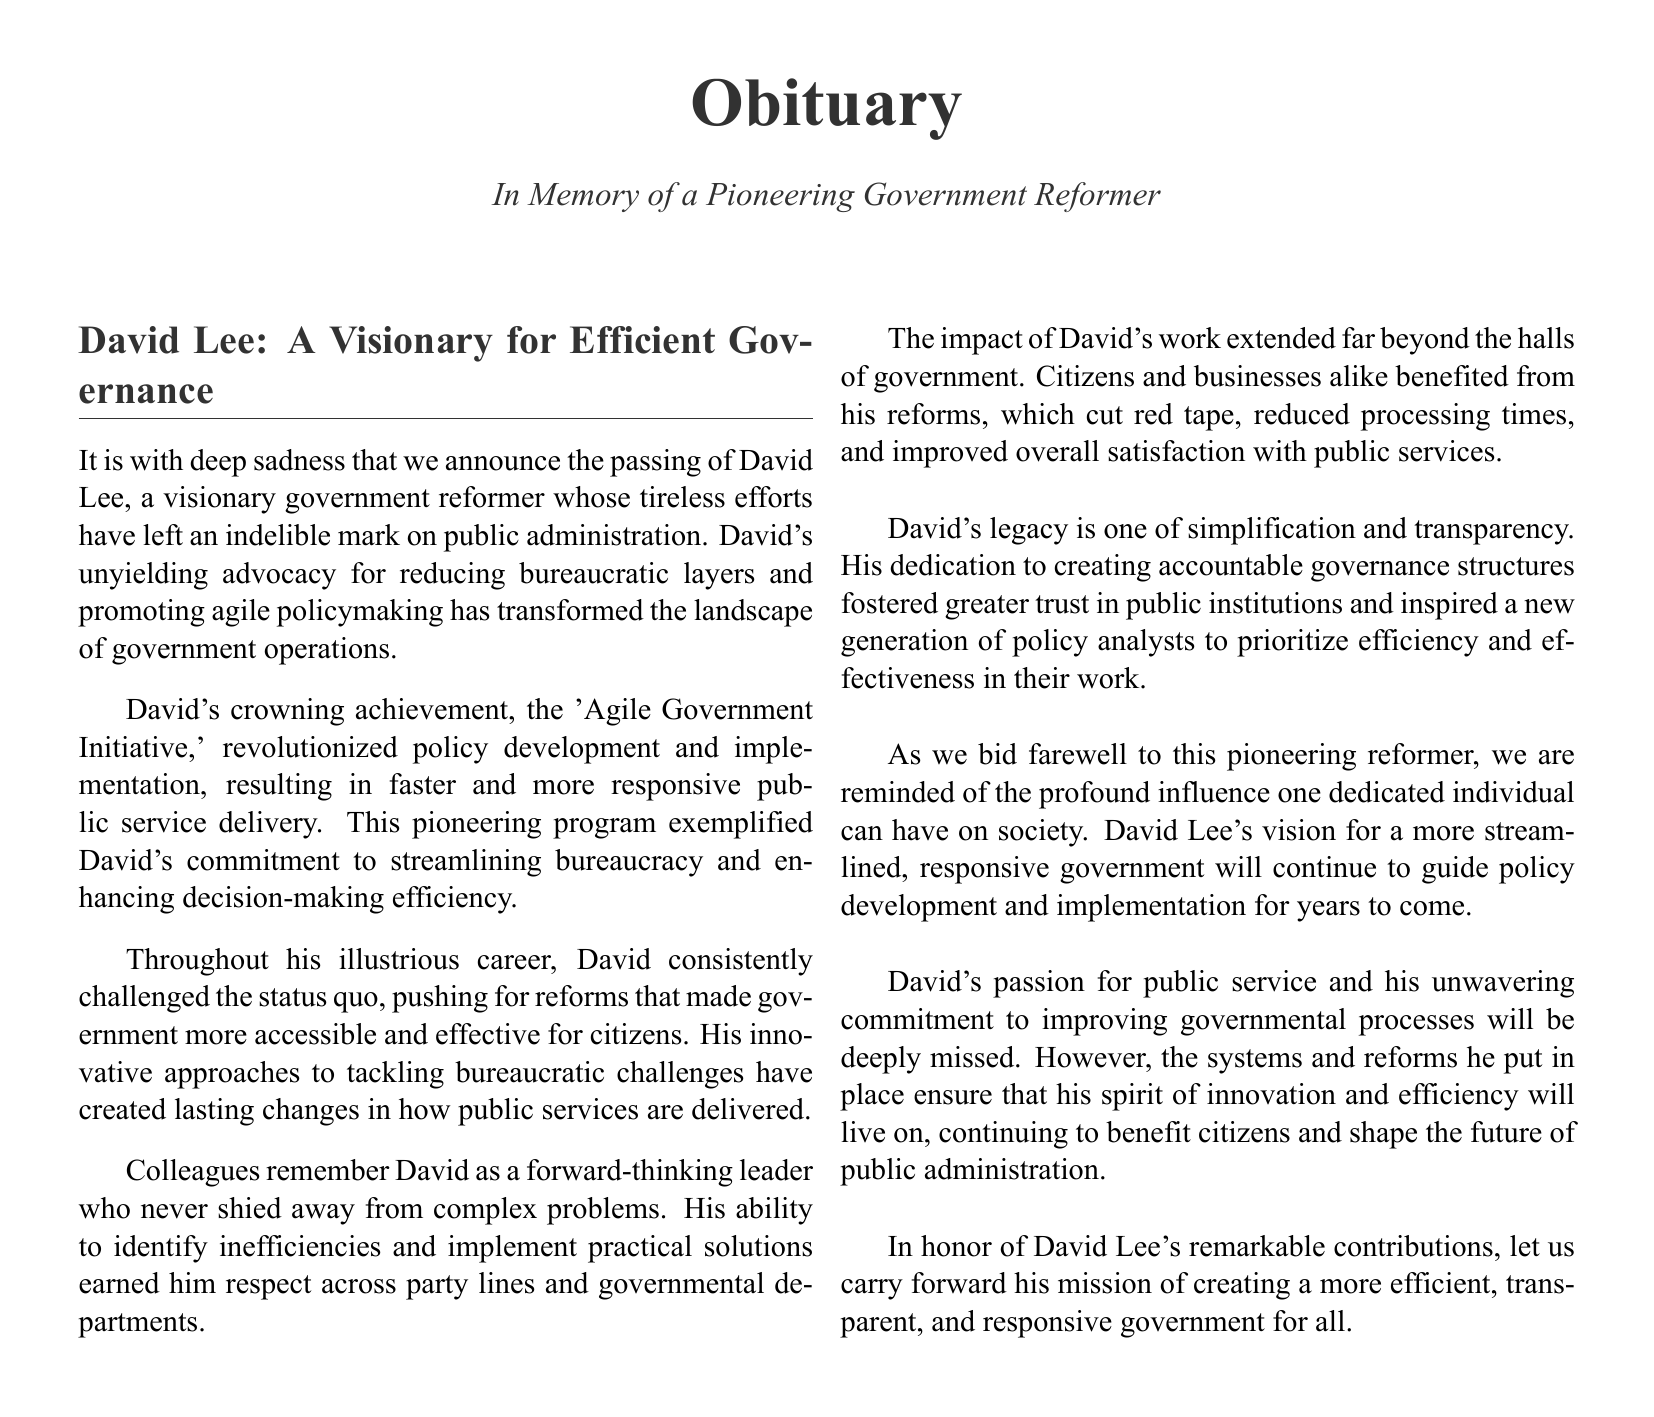What was David Lee known for? David Lee was known for being a visionary government reformer whose advocacy for reducing bureaucratic layers transformed public administration.
Answer: Visionary government reformer What significant program did David Lee implement? The significant program David Lee implemented is known as the 'Agile Government Initiative,' which revolutionized policy development.
Answer: Agile Government Initiative How did David Lee's reforms impact citizens? David Lee's reforms cut red tape, reduced processing times, and improved overall satisfaction with public services for citizens and businesses.
Answer: Cut red tape, reduced processing times, improved satisfaction Who respected David Lee across party lines? Colleagues respected David Lee across party lines and governmental departments for his ability to identify inefficiencies and implement solutions.
Answer: Colleagues What legacy did David Lee leave behind? David Lee's legacy is one of simplification and transparency, fostering greater trust in public institutions and inspiring new policy analysts.
Answer: Simplification and transparency What should be carried forward in honor of David Lee? The mission of creating a more efficient, transparent, and responsive government for all should be carried forward in honor of David Lee.
Answer: Efficient, transparent, responsive government 